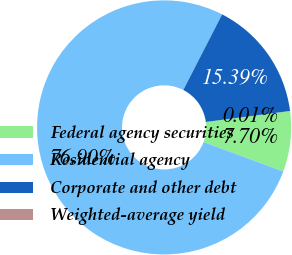Convert chart. <chart><loc_0><loc_0><loc_500><loc_500><pie_chart><fcel>Federal agency securities<fcel>Residential agency<fcel>Corporate and other debt<fcel>Weighted-average yield<nl><fcel>7.7%<fcel>76.9%<fcel>15.39%<fcel>0.01%<nl></chart> 